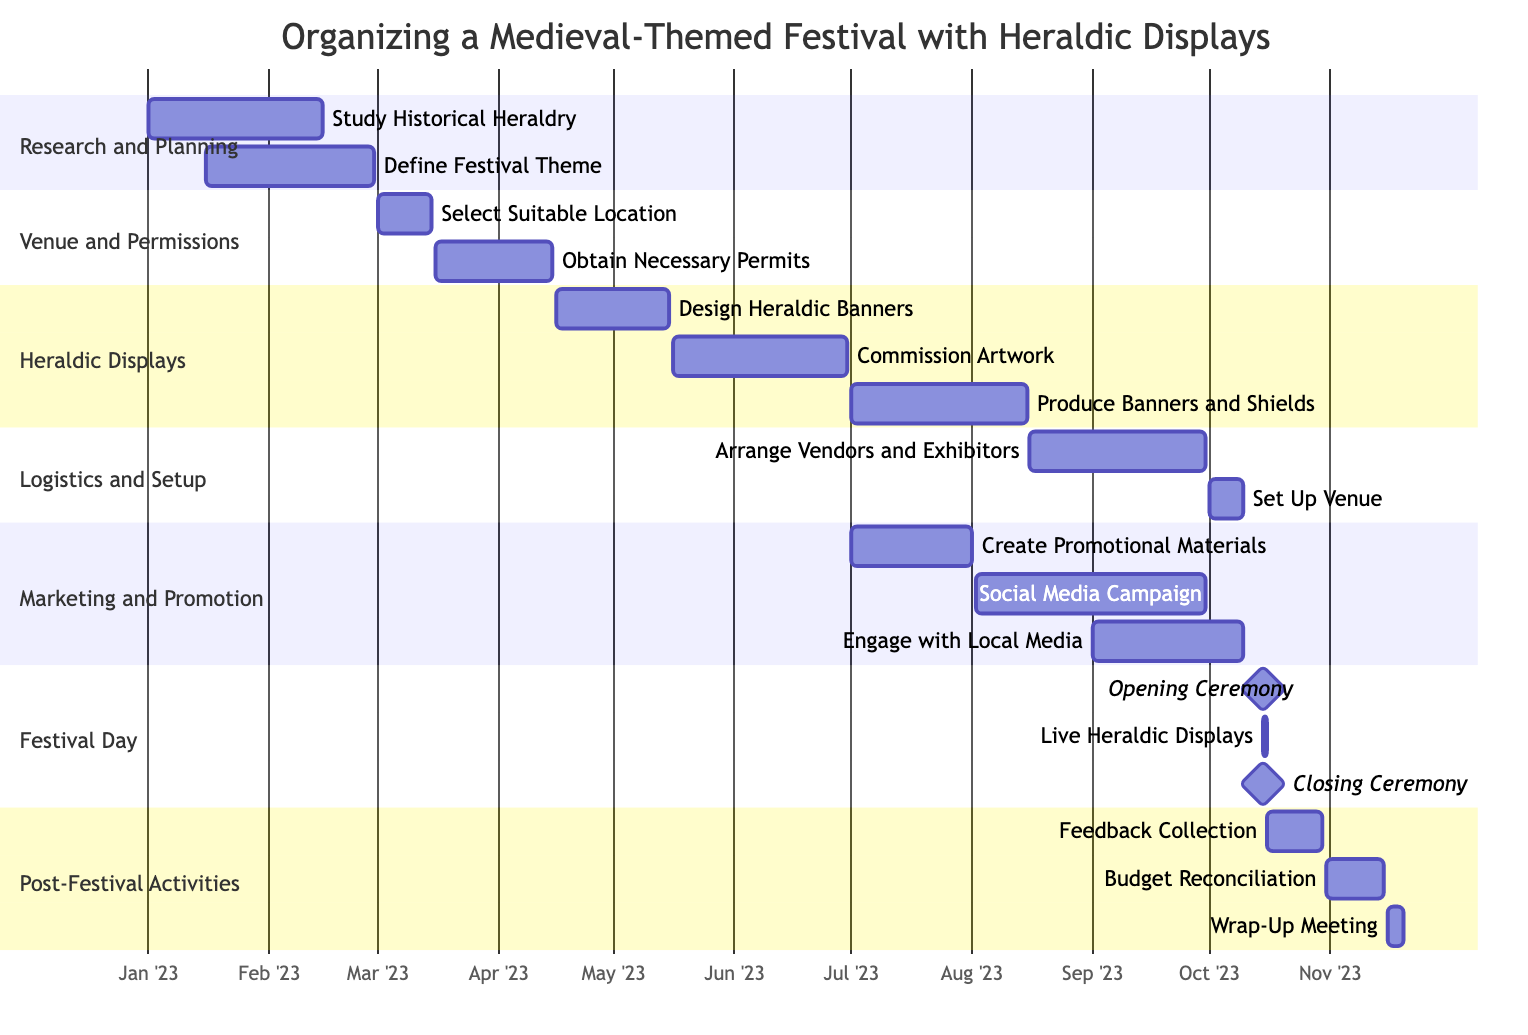What is the duration of the "Define Festival Theme" task? The "Define Festival Theme" task starts on January 16, 2023, and ends on February 28, 2023. To find the duration, count the days from the start to the end date: 28 days in February plus 16 days in January gives a total of 43 days.
Answer: 43 days When does the "Obtain Necessary Permits" task start? The "Obtain Necessary Permits" task is listed under the "Venue and Permissions" section and has a start date of March 16, 2023, as indicated in the timeline.
Answer: March 16, 2023 How many tasks are scheduled before the "Set Up Venue" task? The "Set Up Venue" task is under the "Logistics and Setup" section and starts on October 1, 2023. By counting the tasks listed before it in the timeline, there are five tasks in total that precede this one: two in "Research and Planning", two in "Venue and Permissions", and one in "Heraldic Displays".
Answer: 5 tasks What is the end date of the "Live Heraldic Displays"? The task "Live Heraldic Displays" is scheduled to occur on the festival day, which falls on October 15, 2023. Hence, the end date is the same as the start date in this case.
Answer: October 15, 2023 Which section contains the task "Create Promotional Materials"? The task "Create Promotional Materials" is part of the "Marketing and Promotion" section, as indicated in the structure of the Gantt Chart, which outlines different sections for organizing the festival.
Answer: Marketing and Promotion How many days are there between the "Commission Artwork" task and the "Produce Banners and Shields" task? The "Commission Artwork" task ends on June 30, 2023, and the "Produce Banners and Shields" task starts on July 1, 2023. Since they are back-to-back tasks, there is no gap between them. Hence the difference in days is zero.
Answer: 0 days What is the total number of subtasks under "Logistics and Setup"? There are two subtasks under the "Logistics and Setup" section: "Arrange Vendors and Exhibitors" and "Set Up Venue". By simply counting them, we find there are two subtasks.
Answer: 2 subtasks When is the final task in the festival organization process? The last task listed is "Wrap-Up Meeting" under the "Post-Festival Activities" section, which starts on November 16, 2023, and ends on November 20, 2023. The end date of this task indicates the final task in the timeline.
Answer: November 20, 2023 